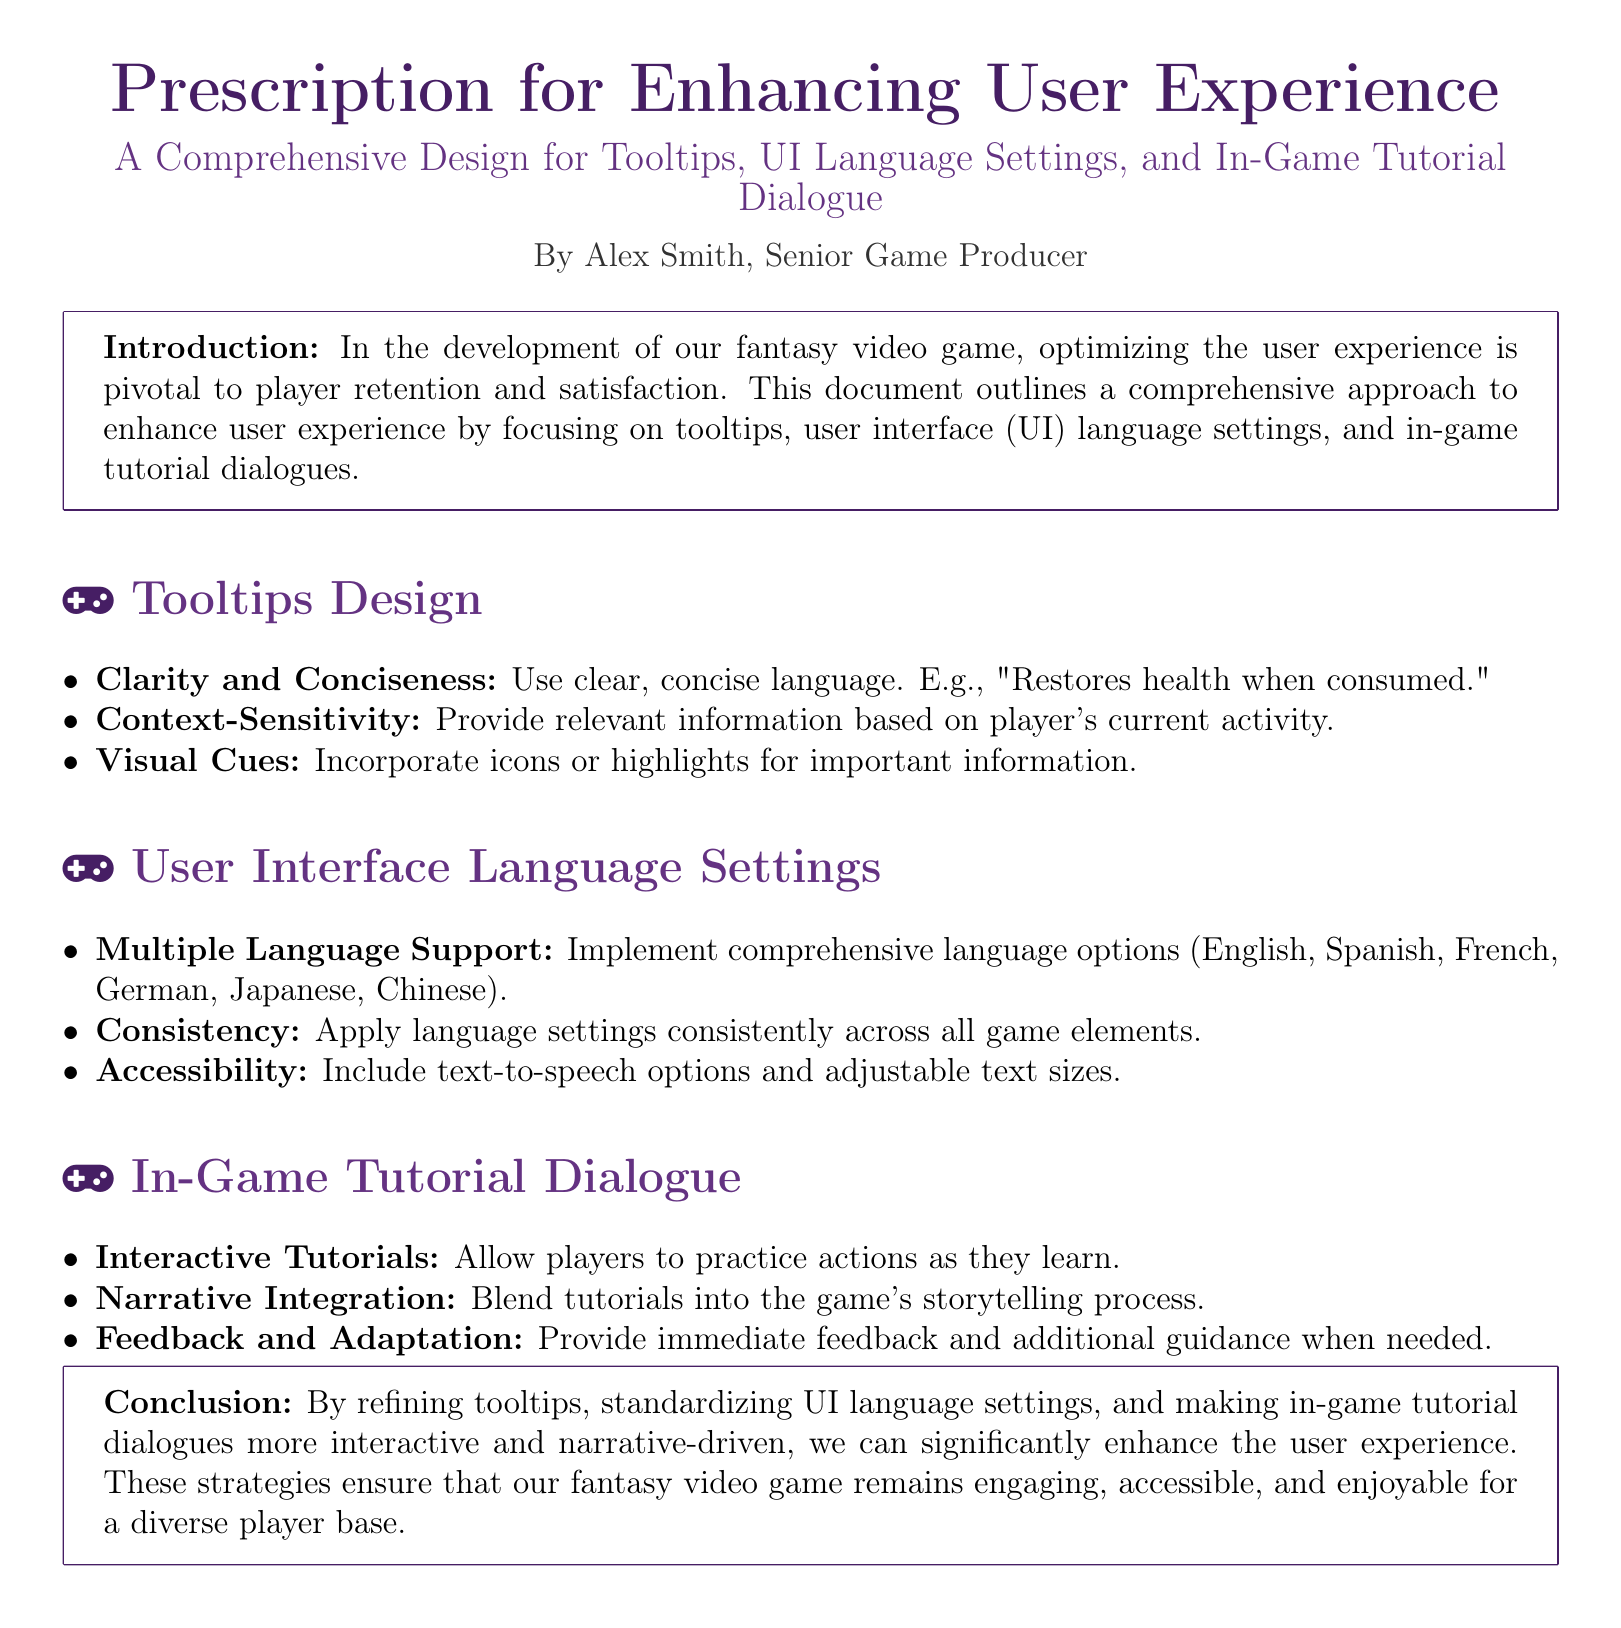What is the title of the document? The title is stated at the beginning of the document.
Answer: Prescription for Enhancing User Experience Who is the author of the document? The author's name is mentioned at the end of the introduction.
Answer: Alex Smith Which section discusses tooltip design? The tooltips design is identified as a dedicated section in the document.
Answer: Tooltips Design What are two languages mentioned for user interface language settings? The document specifies multiple language options in one of its sections.
Answer: Spanish, French What is one of the key features of in-game tutorial dialogues? The document lists a notable aspect of tutorial dialogues.
Answer: Interactive Tutorials How many key areas are identified for enhancing user experience? The document outlines three main areas of focus.
Answer: Three What color is used for the title in the document? The document specifies the RGB color used for the title.
Answer: RGB(70,30,100) What is the purpose of including text-to-speech options? The document mentions the inclusion of this feature under user interface settings for a specific reason.
Answer: Accessibility 